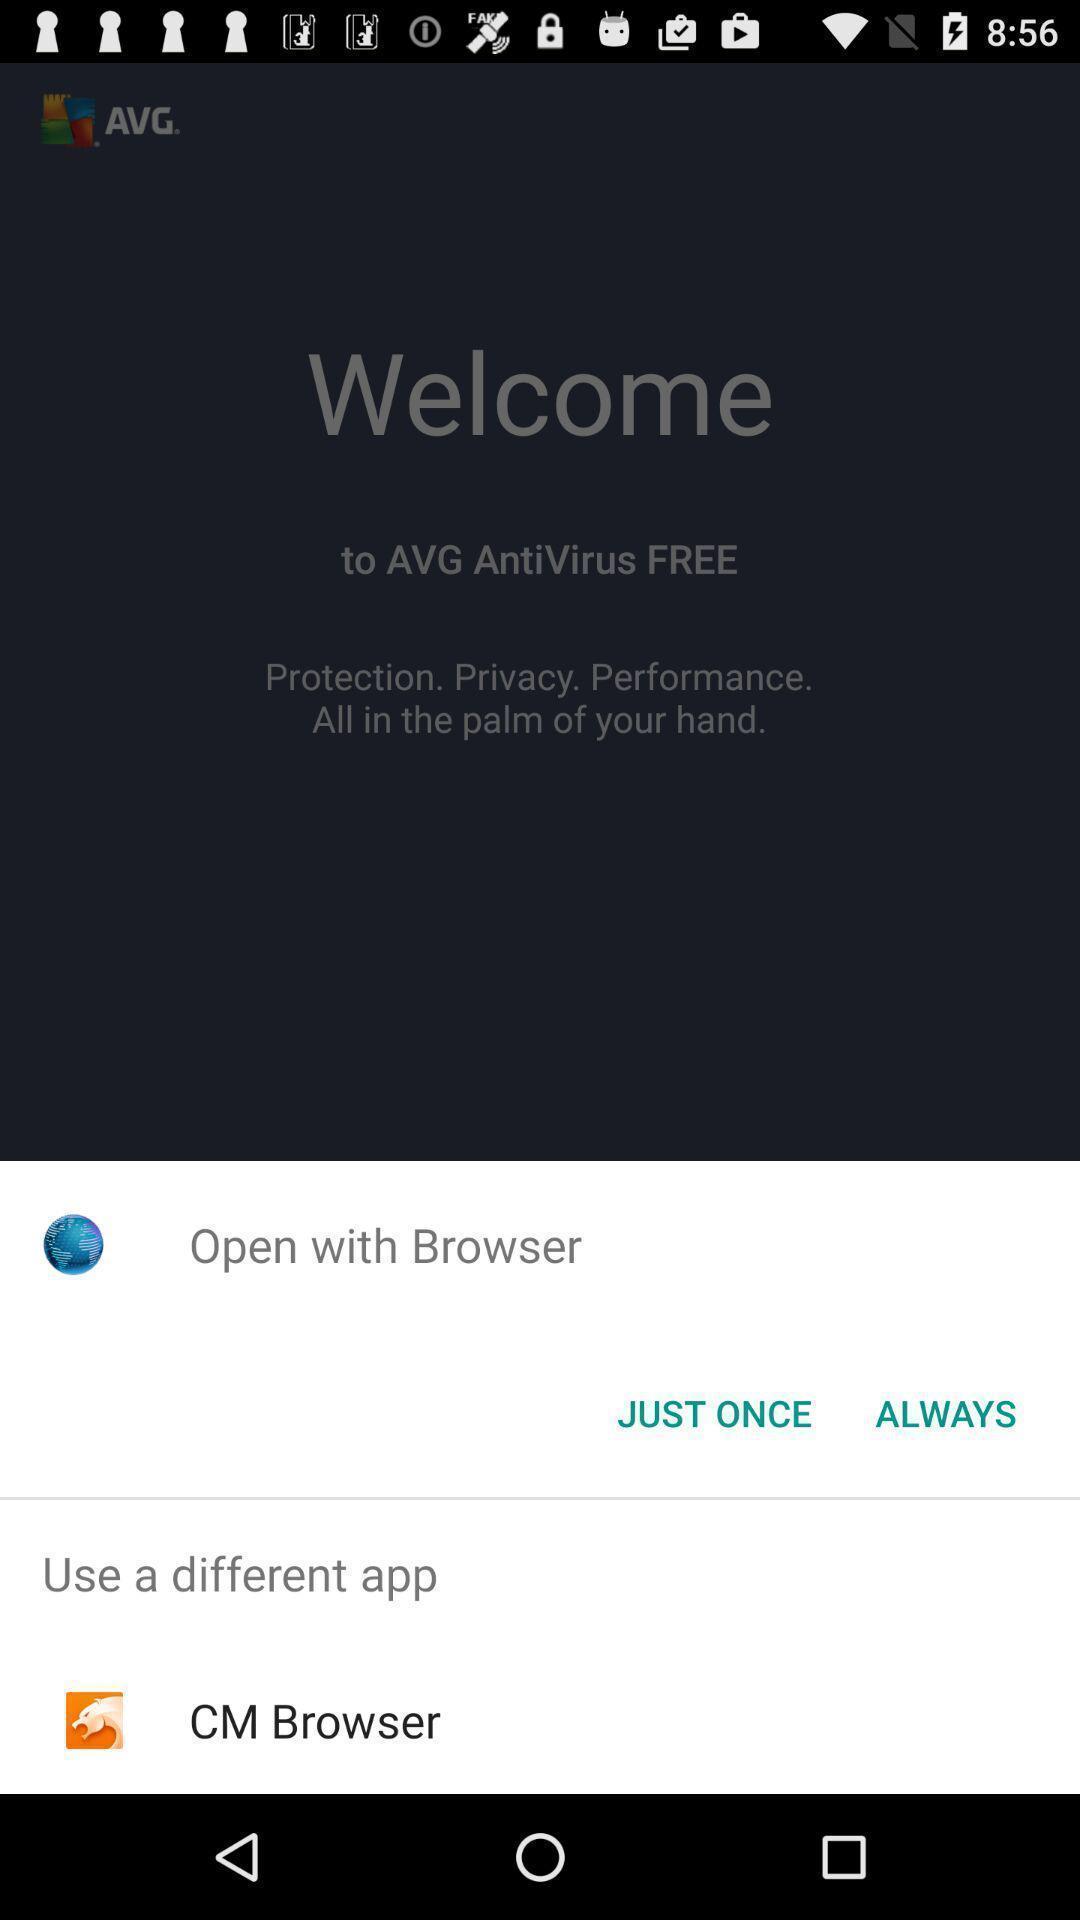Describe the content in this image. Popup displaying apps to open a file in security app. 